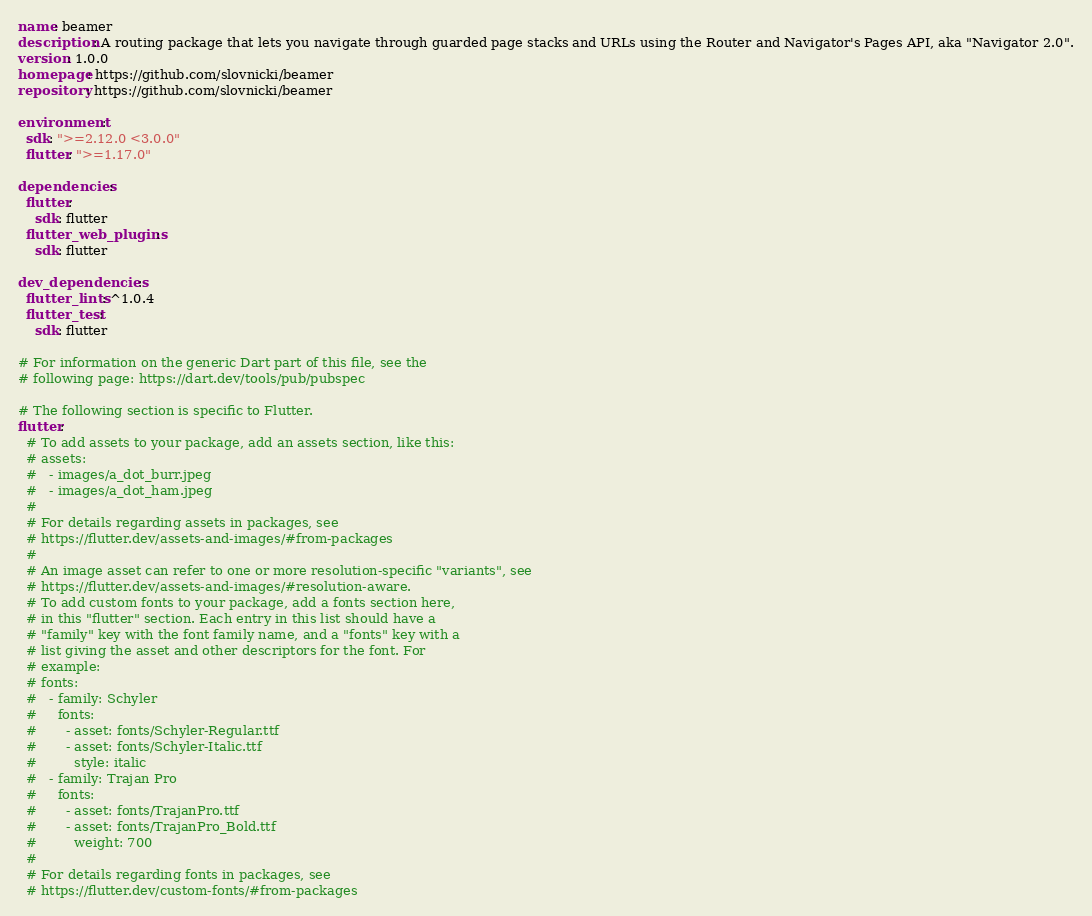<code> <loc_0><loc_0><loc_500><loc_500><_YAML_>name: beamer
description: A routing package that lets you navigate through guarded page stacks and URLs using the Router and Navigator's Pages API, aka "Navigator 2.0".
version: 1.0.0
homepage: https://github.com/slovnicki/beamer
repository: https://github.com/slovnicki/beamer

environment:
  sdk: ">=2.12.0 <3.0.0"
  flutter: ">=1.17.0"

dependencies:
  flutter:
    sdk: flutter
  flutter_web_plugins:
    sdk: flutter

dev_dependencies:
  flutter_lints: ^1.0.4
  flutter_test:
    sdk: flutter

# For information on the generic Dart part of this file, see the
# following page: https://dart.dev/tools/pub/pubspec

# The following section is specific to Flutter.
flutter:
  # To add assets to your package, add an assets section, like this:
  # assets:
  #   - images/a_dot_burr.jpeg
  #   - images/a_dot_ham.jpeg
  #
  # For details regarding assets in packages, see
  # https://flutter.dev/assets-and-images/#from-packages
  #
  # An image asset can refer to one or more resolution-specific "variants", see
  # https://flutter.dev/assets-and-images/#resolution-aware.
  # To add custom fonts to your package, add a fonts section here,
  # in this "flutter" section. Each entry in this list should have a
  # "family" key with the font family name, and a "fonts" key with a
  # list giving the asset and other descriptors for the font. For
  # example:
  # fonts:
  #   - family: Schyler
  #     fonts:
  #       - asset: fonts/Schyler-Regular.ttf
  #       - asset: fonts/Schyler-Italic.ttf
  #         style: italic
  #   - family: Trajan Pro
  #     fonts:
  #       - asset: fonts/TrajanPro.ttf
  #       - asset: fonts/TrajanPro_Bold.ttf
  #         weight: 700
  #
  # For details regarding fonts in packages, see
  # https://flutter.dev/custom-fonts/#from-packages
</code> 